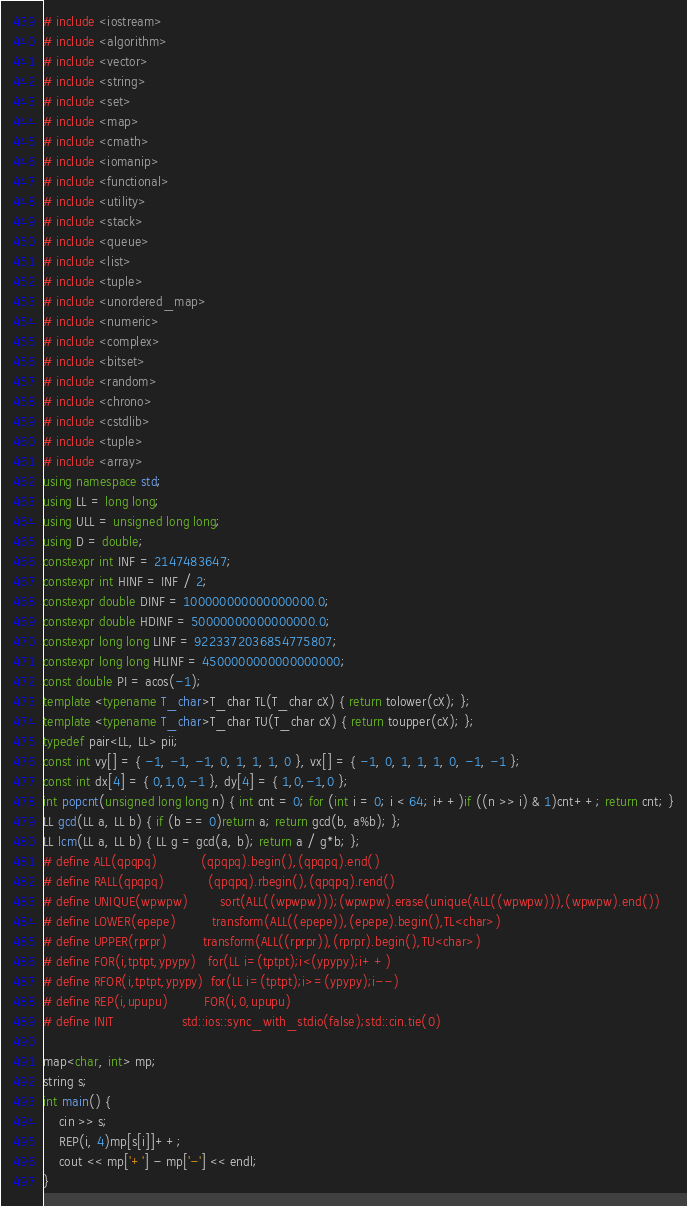<code> <loc_0><loc_0><loc_500><loc_500><_C++_># include <iostream>
# include <algorithm>
# include <vector>
# include <string>
# include <set>
# include <map>
# include <cmath>
# include <iomanip>
# include <functional>
# include <utility>
# include <stack>
# include <queue>
# include <list>
# include <tuple>
# include <unordered_map>
# include <numeric>
# include <complex>
# include <bitset>
# include <random>
# include <chrono>
# include <cstdlib>
# include <tuple>
# include <array>
using namespace std;
using LL = long long;
using ULL = unsigned long long;
using D = double;
constexpr int INF = 2147483647;
constexpr int HINF = INF / 2;
constexpr double DINF = 100000000000000000.0;
constexpr double HDINF = 50000000000000000.0;
constexpr long long LINF = 9223372036854775807;
constexpr long long HLINF = 4500000000000000000;
const double PI = acos(-1);
template <typename T_char>T_char TL(T_char cX) { return tolower(cX); };
template <typename T_char>T_char TU(T_char cX) { return toupper(cX); };
typedef pair<LL, LL> pii;
const int vy[] = { -1, -1, -1, 0, 1, 1, 1, 0 }, vx[] = { -1, 0, 1, 1, 1, 0, -1, -1 };
const int dx[4] = { 0,1,0,-1 }, dy[4] = { 1,0,-1,0 };
int popcnt(unsigned long long n) { int cnt = 0; for (int i = 0; i < 64; i++)if ((n >> i) & 1)cnt++; return cnt; }
LL gcd(LL a, LL b) { if (b == 0)return a; return gcd(b, a%b); };
LL lcm(LL a, LL b) { LL g = gcd(a, b); return a / g*b; };
# define ALL(qpqpq)           (qpqpq).begin(),(qpqpq).end()
# define RALL(qpqpq)           (qpqpq).rbegin(),(qpqpq).rend()
# define UNIQUE(wpwpw)        sort(ALL((wpwpw)));(wpwpw).erase(unique(ALL((wpwpw))),(wpwpw).end())
# define LOWER(epepe)         transform(ALL((epepe)),(epepe).begin(),TL<char>)
# define UPPER(rprpr)         transform(ALL((rprpr)),(rprpr).begin(),TU<char>)
# define FOR(i,tptpt,ypypy)   for(LL i=(tptpt);i<(ypypy);i++)
# define RFOR(i,tptpt,ypypy)  for(LL i=(tptpt);i>=(ypypy);i--)
# define REP(i,upupu)         FOR(i,0,upupu)
# define INIT                 std::ios::sync_with_stdio(false);std::cin.tie(0)

map<char, int> mp;
string s;
int main() {
	cin >> s;
	REP(i, 4)mp[s[i]]++;
	cout << mp['+'] - mp['-'] << endl;
}</code> 